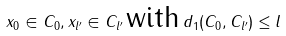Convert formula to latex. <formula><loc_0><loc_0><loc_500><loc_500>x _ { 0 } \in C _ { 0 } , x _ { l ^ { \prime } } \in C _ { l ^ { \prime } } \, \text {with} \, d _ { 1 } ( C _ { 0 } , C _ { l ^ { \prime } } ) \leq l</formula> 